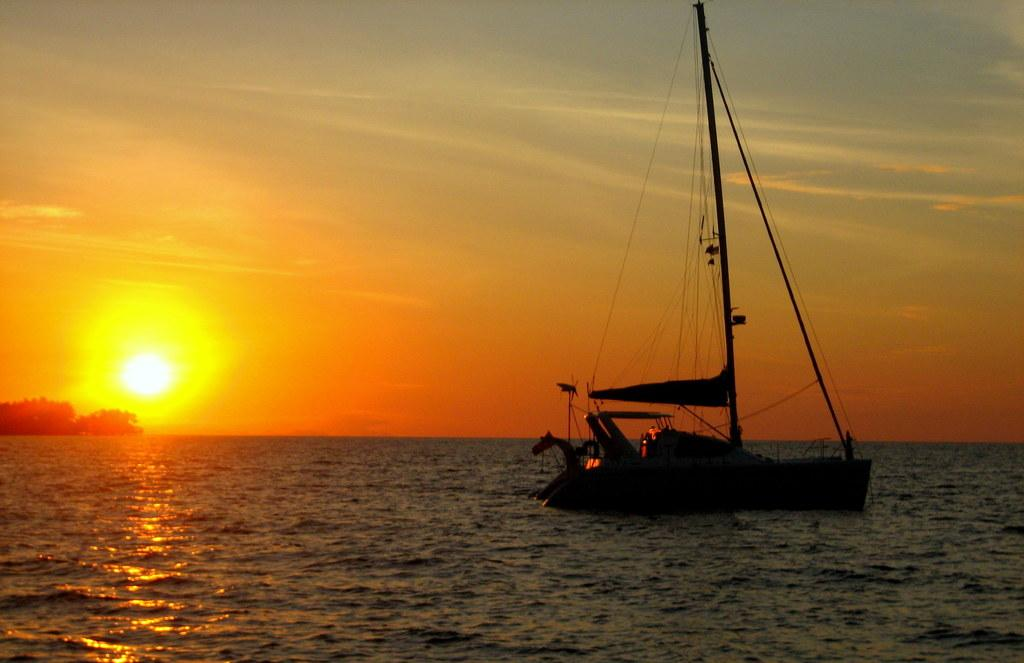What time of day was the image taken? The image was taken during sunset. What is on the surface of the river in the image? There is a boat on the surface of the river in the image. What can be seen in the background of the image? Trees and the sky are visible in the background of the image. What type of paper is visible in the image? There is no paper present in the image. What material is the boat made of in the image? The image does not provide information about the material the boat is made of. 